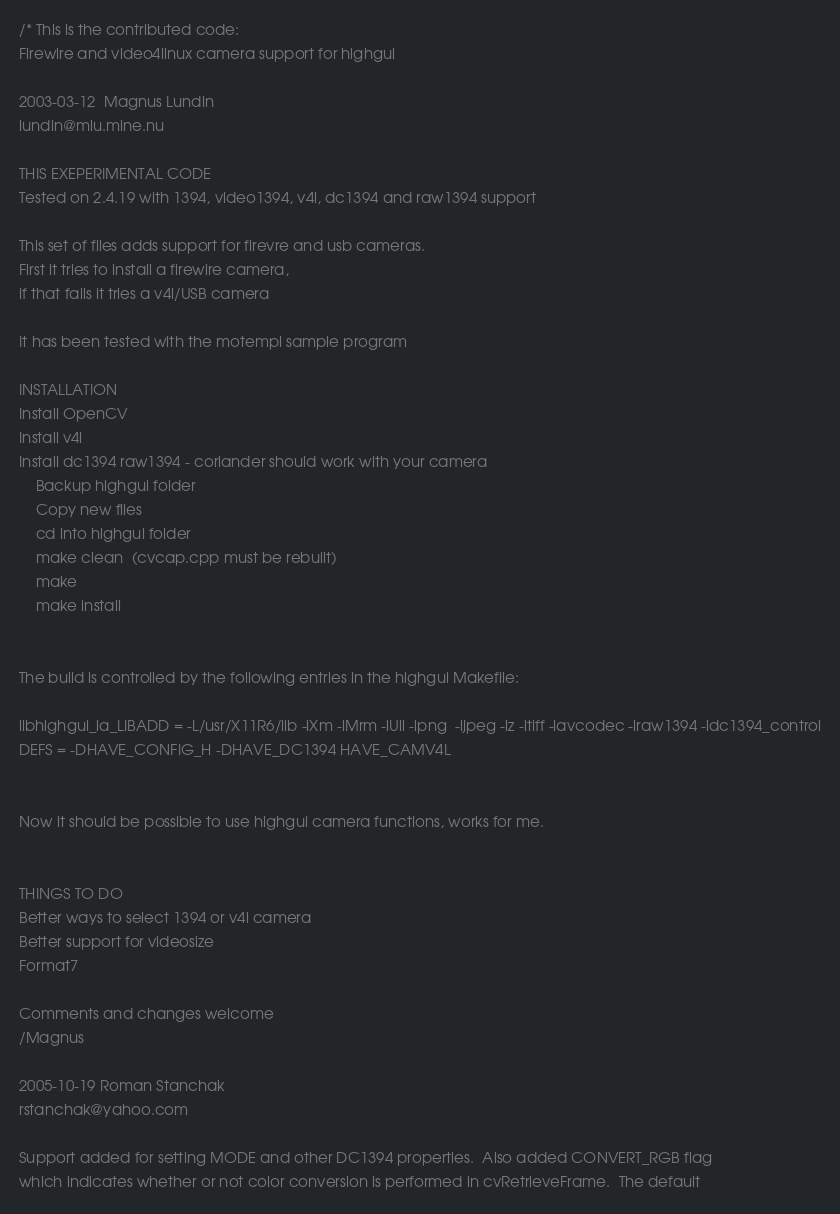Convert code to text. <code><loc_0><loc_0><loc_500><loc_500><_C++_>/* This is the contributed code:
Firewire and video4linux camera support for highgui

2003-03-12  Magnus Lundin
lundin@mlu.mine.nu

THIS EXEPERIMENTAL CODE
Tested on 2.4.19 with 1394, video1394, v4l, dc1394 and raw1394 support

This set of files adds support for firevre and usb cameras.
First it tries to install a firewire camera,
if that fails it tries a v4l/USB camera

It has been tested with the motempl sample program

INSTALLATION
Install OpenCV
Install v4l
Install dc1394 raw1394 - coriander should work with your camera
    Backup highgui folder
    Copy new files
    cd into highgui folder
    make clean  (cvcap.cpp must be rebuilt)
    make
    make install


The build is controlled by the following entries in the highgui Makefile:

libhighgui_la_LIBADD = -L/usr/X11R6/lib -lXm -lMrm -lUil -lpng  -ljpeg -lz -ltiff -lavcodec -lraw1394 -ldc1394_control
DEFS = -DHAVE_CONFIG_H -DHAVE_DC1394 HAVE_CAMV4L


Now it should be possible to use highgui camera functions, works for me.


THINGS TO DO
Better ways to select 1394 or v4l camera
Better support for videosize
Format7

Comments and changes welcome
/Magnus

2005-10-19 Roman Stanchak
rstanchak@yahoo.com

Support added for setting MODE and other DC1394 properties.  Also added CONVERT_RGB flag
which indicates whether or not color conversion is performed in cvRetrieveFrame.  The default</code> 